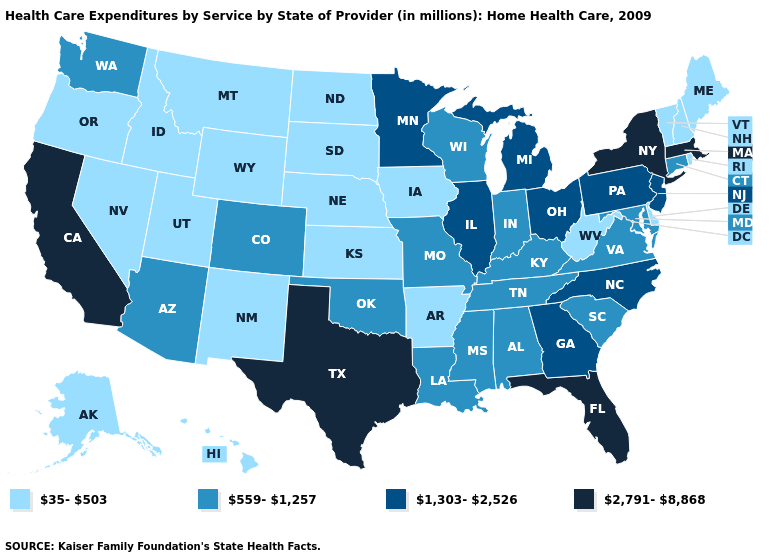Among the states that border Alabama , does Mississippi have the highest value?
Write a very short answer. No. What is the value of Nebraska?
Short answer required. 35-503. Does Minnesota have a lower value than South Dakota?
Be succinct. No. What is the lowest value in the USA?
Concise answer only. 35-503. What is the highest value in states that border Wisconsin?
Give a very brief answer. 1,303-2,526. Name the states that have a value in the range 1,303-2,526?
Be succinct. Georgia, Illinois, Michigan, Minnesota, New Jersey, North Carolina, Ohio, Pennsylvania. Name the states that have a value in the range 35-503?
Be succinct. Alaska, Arkansas, Delaware, Hawaii, Idaho, Iowa, Kansas, Maine, Montana, Nebraska, Nevada, New Hampshire, New Mexico, North Dakota, Oregon, Rhode Island, South Dakota, Utah, Vermont, West Virginia, Wyoming. What is the value of Washington?
Short answer required. 559-1,257. What is the highest value in states that border Washington?
Keep it brief. 35-503. Which states have the highest value in the USA?
Quick response, please. California, Florida, Massachusetts, New York, Texas. What is the value of Delaware?
Be succinct. 35-503. Does Arkansas have the lowest value in the South?
Concise answer only. Yes. What is the lowest value in the USA?
Quick response, please. 35-503. What is the lowest value in the Northeast?
Give a very brief answer. 35-503. Does the first symbol in the legend represent the smallest category?
Answer briefly. Yes. 